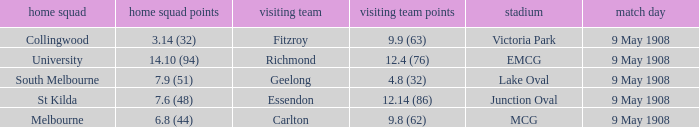Name the away team score for lake oval 4.8 (32). 